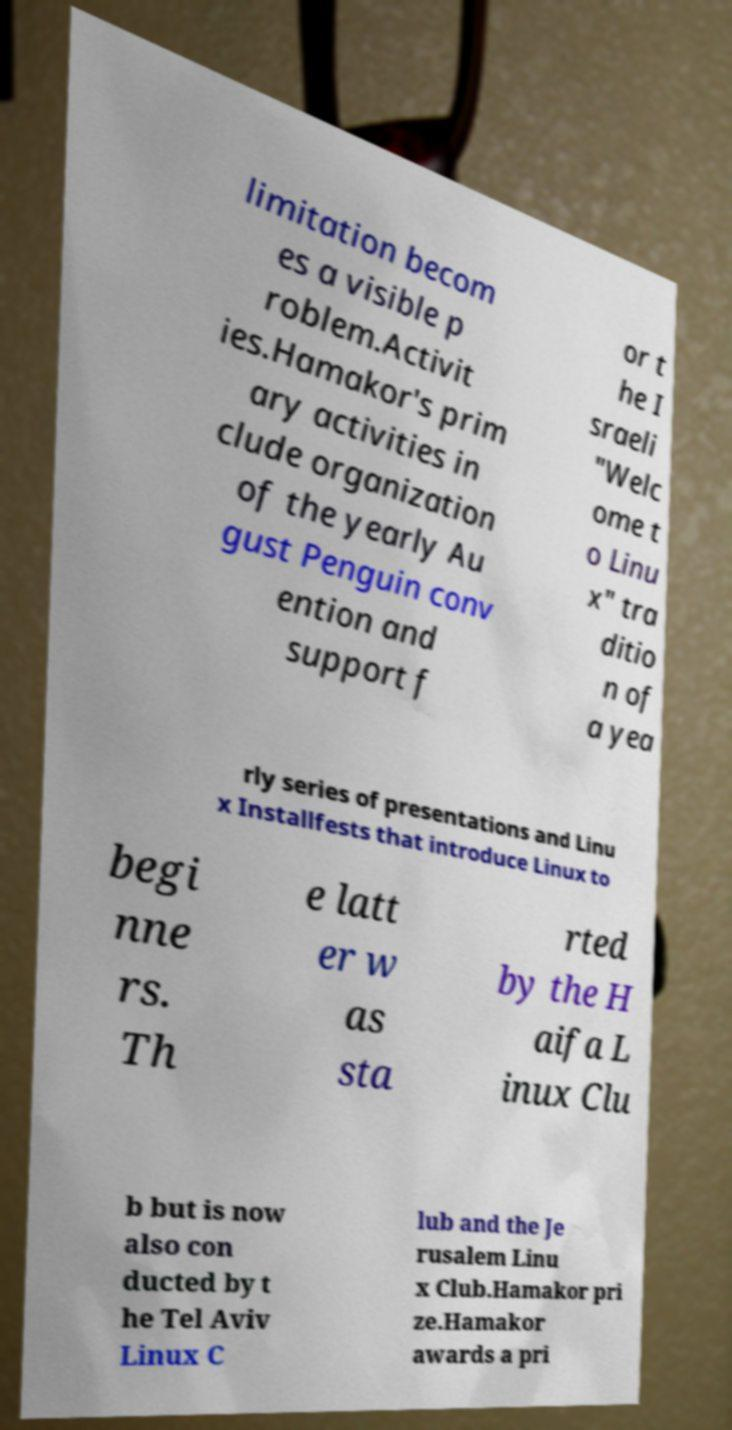What messages or text are displayed in this image? I need them in a readable, typed format. limitation becom es a visible p roblem.Activit ies.Hamakor's prim ary activities in clude organization of the yearly Au gust Penguin conv ention and support f or t he I sraeli "Welc ome t o Linu x" tra ditio n of a yea rly series of presentations and Linu x Installfests that introduce Linux to begi nne rs. Th e latt er w as sta rted by the H aifa L inux Clu b but is now also con ducted by t he Tel Aviv Linux C lub and the Je rusalem Linu x Club.Hamakor pri ze.Hamakor awards a pri 